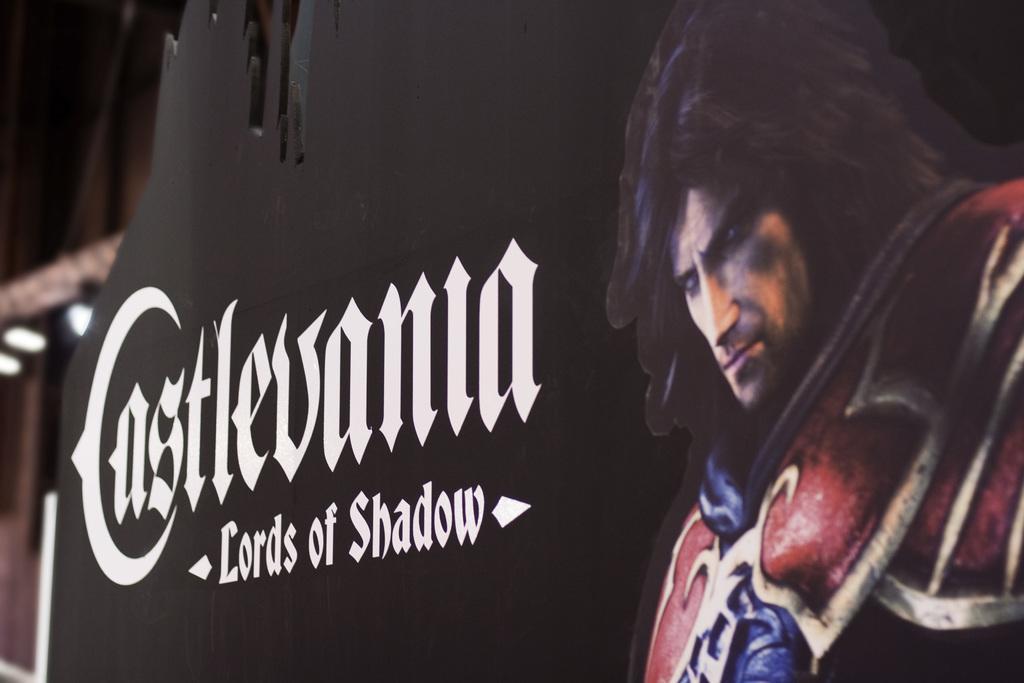Please provide a concise description of this image. In the image there is a black frame and on that there is some text and an image of a person are printed. 